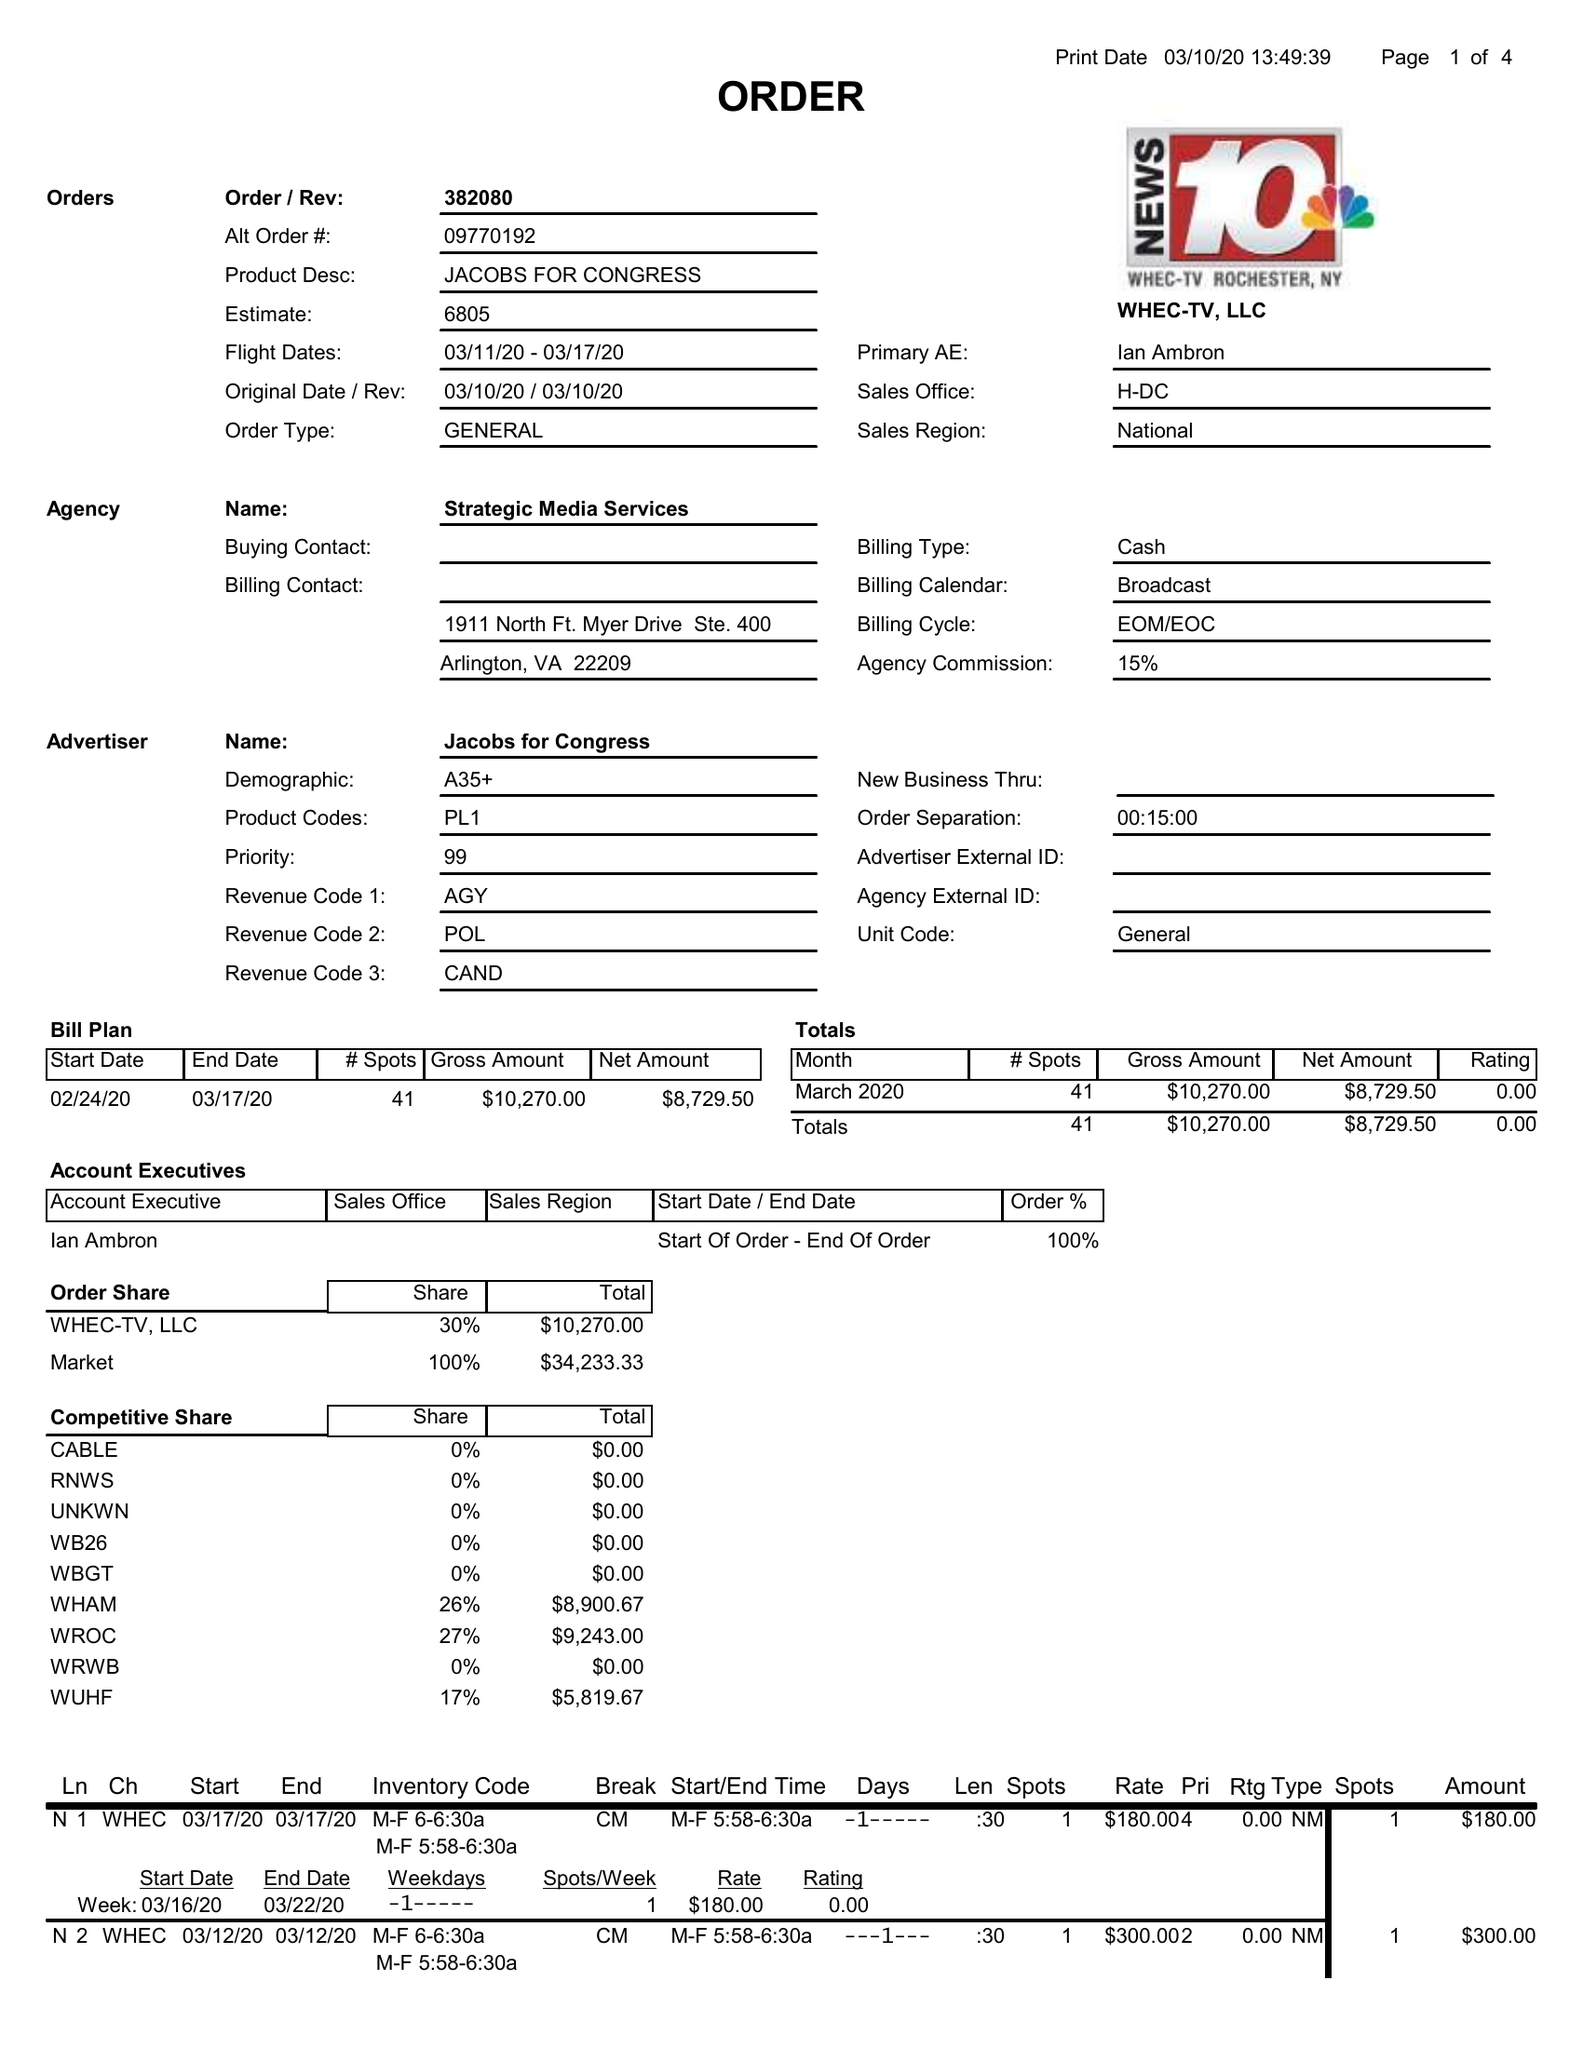What is the value for the contract_num?
Answer the question using a single word or phrase. 382080 